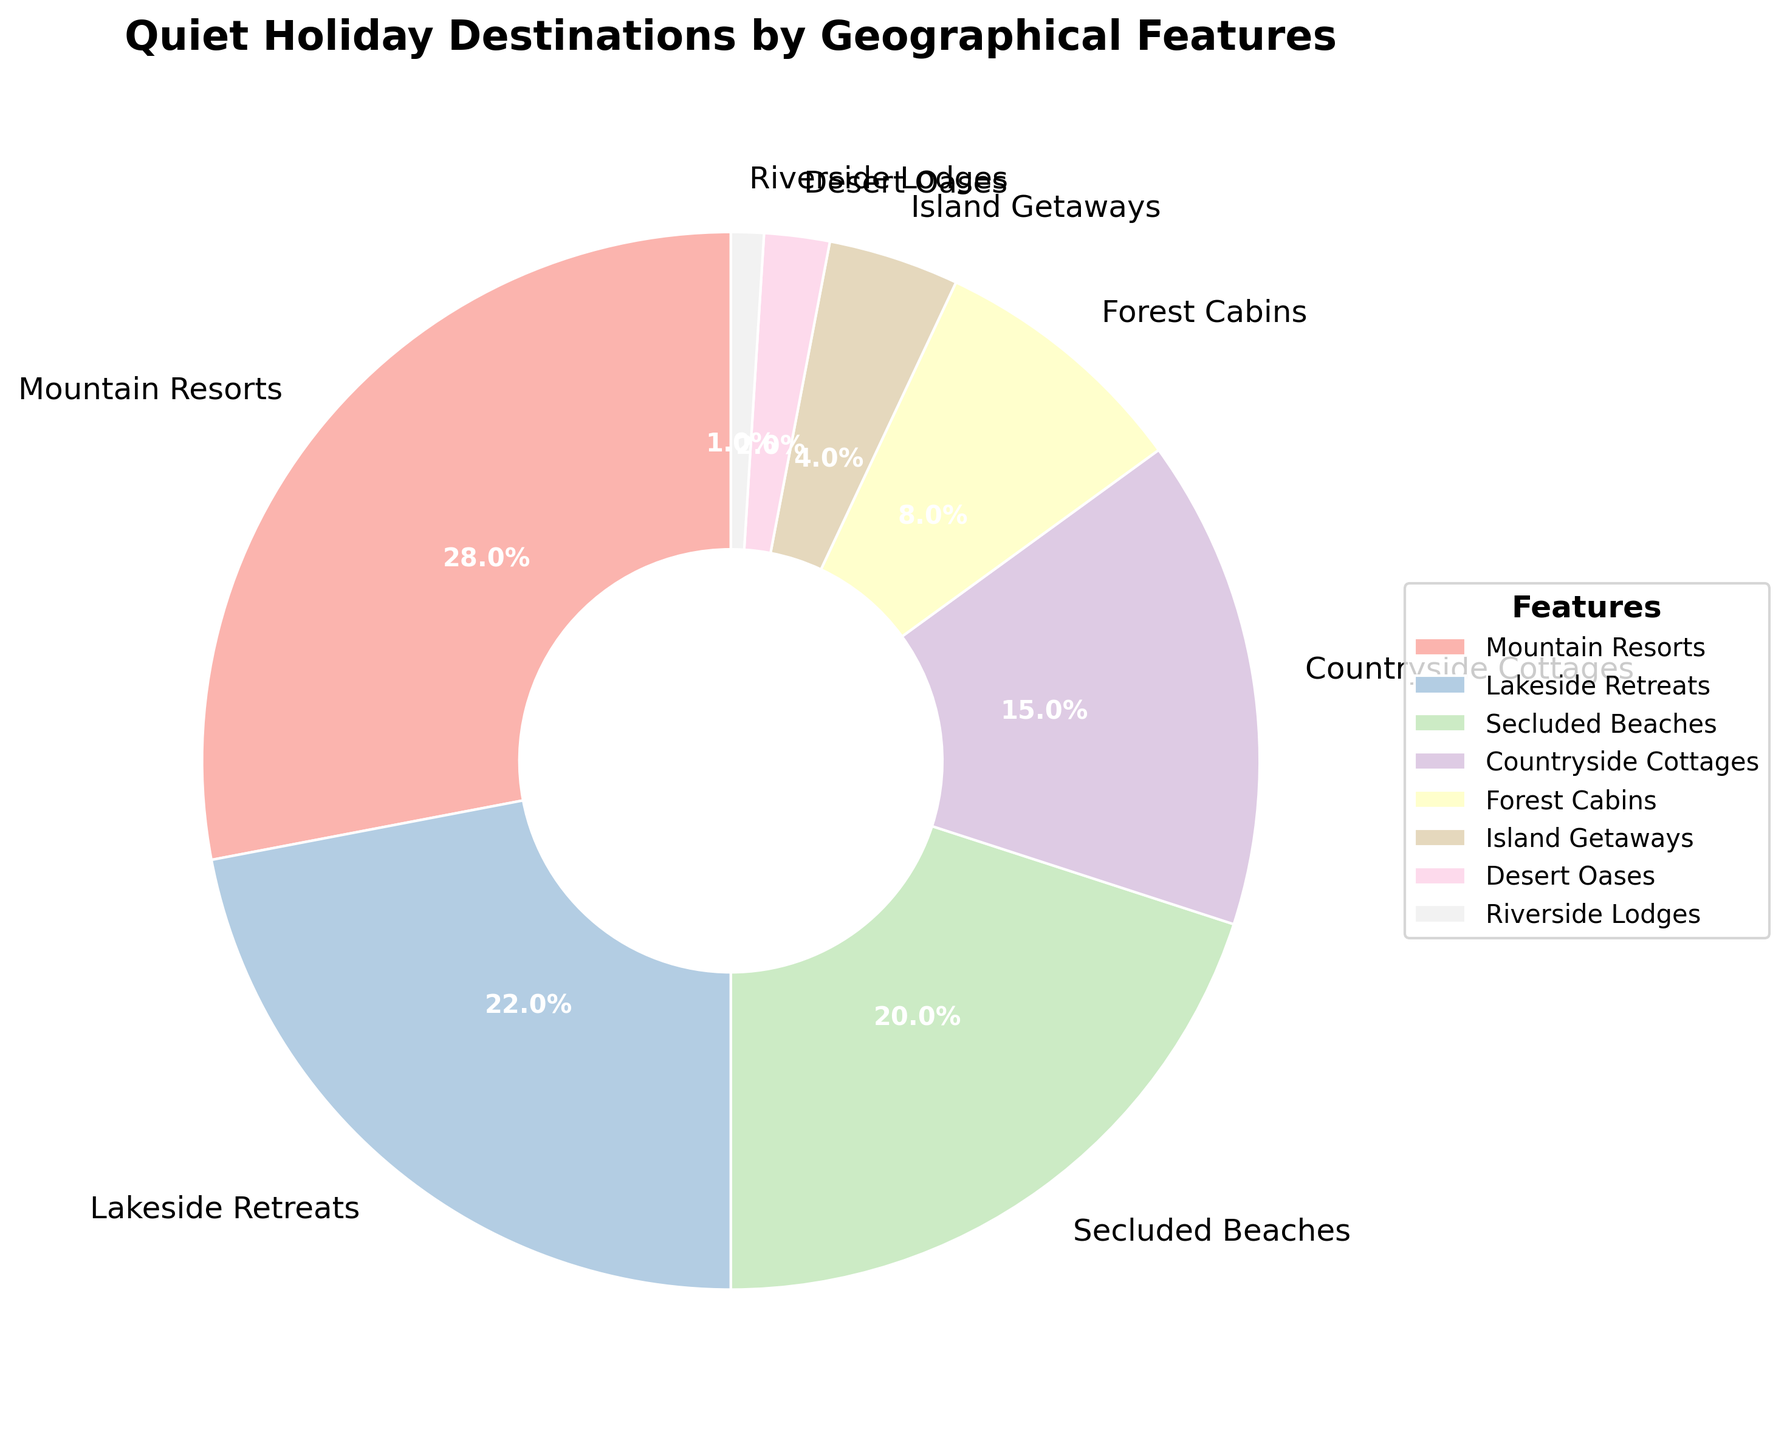Which geographical feature has the highest percentage of quiet holiday destinations? Look at the slice with the largest size. The "Mountain Resorts" section takes up the most space, corresponding to 28%.
Answer: Mountain Resorts What percentage of quiet holiday destinations are either Secluded Beaches or Lakeside Retreats? Find the percentages for both features: Secluded Beaches is 20% and Lakeside Retreats is 22%. Summing them: 20 + 22 = 42%.
Answer: 42% Which geographical feature has the smallest percentage of quiet holiday destinations? Look at the smallest slice on the pie chart. The "Riverside Lodges" section has the least area, corresponding to 1%.
Answer: Riverside Lodges Are Countryside Cottages more popular than Forest Cabins for quiet holidays? Compare the sizes and percentages: Countryside Cottages are 15% and Forest Cabins are 8%. 15% is greater than 8%.
Answer: Yes How many geographical features make up at least 20% of quiet holiday destinations? Identify the features with percentages 20% or more: Mountain Resorts (28%), Lakeside Retreats (22%), and Secluded Beaches (20%). That’s 3 features.
Answer: 3 What is the combined percentage of Island Getaways and Desert Oases? Find the percentages for both features: Island Getaways is 4% and Desert Oases is 2%. Summing them: 4 + 2 = 6%.
Answer: 6% Is the percentage of Lakeside Retreats more than twice that of Forest Cabins? Compare the percentages: Lakeside Retreats is 22% and Forest Cabins is 8%. Twice 8% is 16%, and 22% is indeed more than 16%.
Answer: Yes Which feature(s) have a percentage less than 10%? Identify the features with percentages below 10%: Forest Cabins (8%), Island Getaways (4%), Desert Oases (2%), and Riverside Lodges (1%).
Answer: Forest Cabins, Island Getaways, Desert Oases, Riverside Lodges How much larger is the percentage of Mountain Resorts compared to Secluded Beaches? Subtract the percentage of Secluded Beaches from Mountain Resorts: 28% - 20% = 8%.
Answer: 8% Which features fall in the middle range, between 10% and 25%? Identify the features within this range: Lakeside Retreats (22%), Secluded Beaches (20%), and Countryside Cottages (15%).
Answer: Lakeside Retreats, Secluded Beaches, Countryside Cottages 